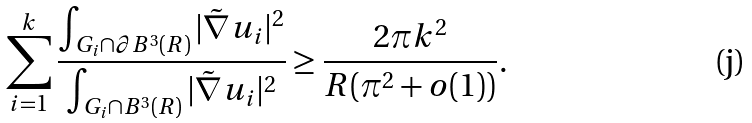<formula> <loc_0><loc_0><loc_500><loc_500>\sum _ { i = 1 } ^ { k } \frac { \int _ { G _ { i } \cap \partial B ^ { 3 } ( R ) } | \tilde { \nabla } u _ { i } | ^ { 2 } } { \int _ { G _ { i } \cap B ^ { 3 } ( R ) } | \tilde { \nabla } u _ { i } | ^ { 2 } } \geq \frac { 2 \pi k ^ { 2 } } { R ( \pi ^ { 2 } + o ( 1 ) ) } .</formula> 